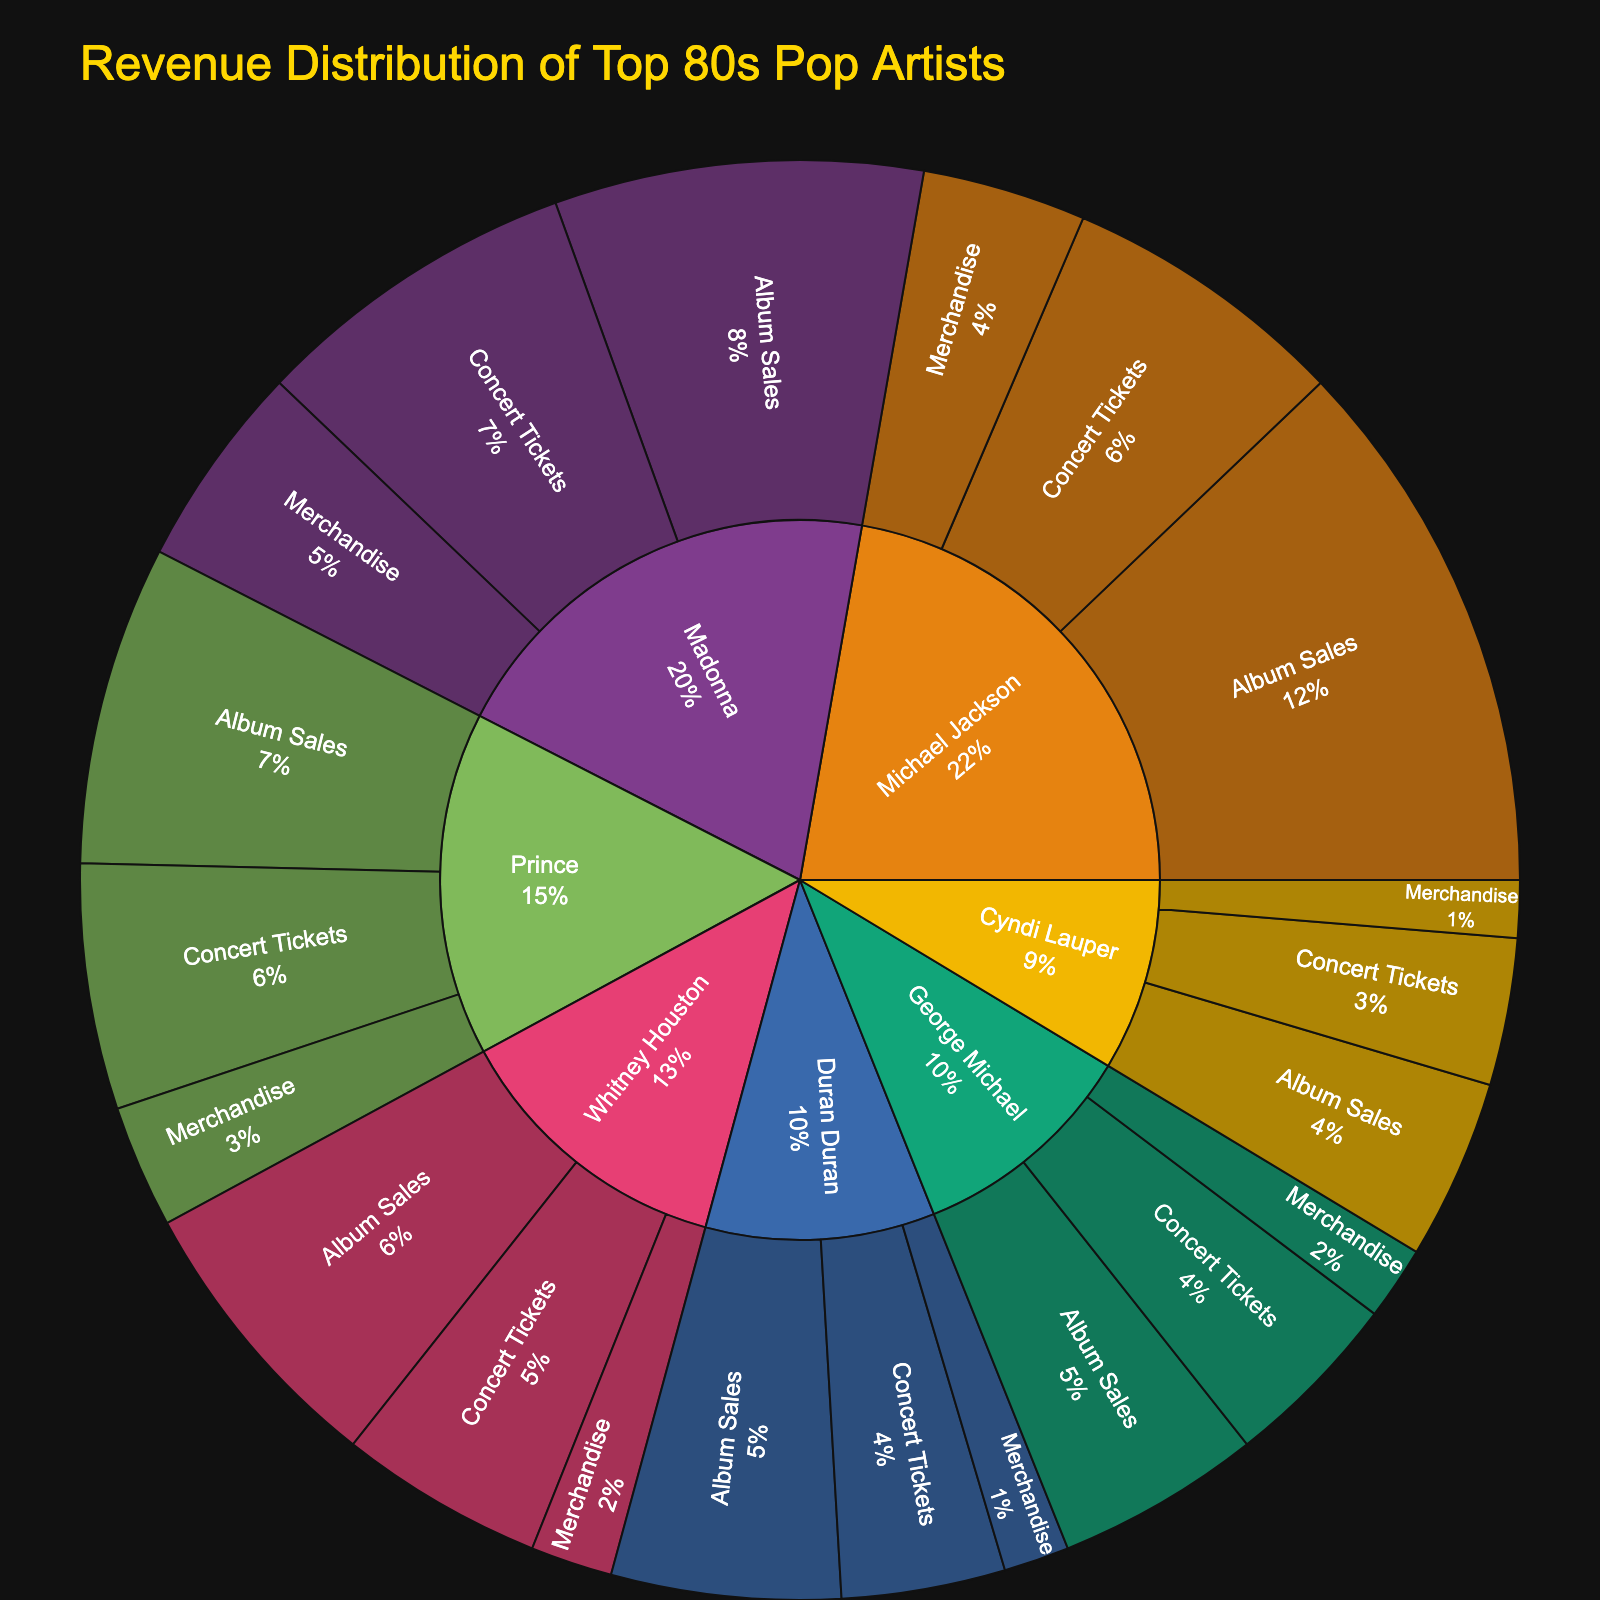what is the total revenue of Michael Jackson? The sunburst plot shows the revenue distribution for each subcategory under Michael Jackson. Summing up the values for Album Sales ($66M), Concert Tickets ($35M), and Merchandise ($20M) gives the total revenue. 66 + 35 + 20 = 121
Answer: 121 which artist has the highest revenue from concert tickets? Referring to each artist's revenue from Concert Tickets, Michael Jackson has $35M, which is the highest compared to others: Madonna ($40M), Prince ($30M), Whitney Houston ($25M), Duran Duran ($20M), Cyndi Lauper ($18M), and George Michael ($22M).
Answer: Madonna what's the percentage revenue from merchandise for Madonna compared to her total revenue? First, find Madonna's total revenue by summing up Album Sales ($45M), Concert Tickets ($40M), and Merchandise ($25M), which is 45 + 40 + 25 = 110. The percentage is then calculated by (25/110) * 100, which is approximately 22.73%.
Answer: 22.73% who generates more total revenue, Prince or Whitney Houston? Calculate the total revenue for both artists. Prince: Album Sales ($39M) + Concert Tickets ($30M) + Merchandise ($15M) = 39 + 30 + 15 = 84. Whitney Houston: Album Sales ($35M) + Concert Tickets ($25M) + Merchandise ($10M) = 35 + 25 + 10 = 70.
Answer: Prince what is the title of the plot? The title is prominently displayed at the top of the plot.
Answer: Revenue Distribution of Top 80s Pop Artists which category contributes most to George Michael's total revenue? Looking at George Michael's data, Album Sales ($25M), Concert Tickets ($22M), and Merchandise ($9M). Album Sales is the highest category.
Answer: Album Sales how much revenue has Duran Duran generated from merchandise? The plot shows Duran Duran's revenue distribution, with Merchandise contributing $8M.
Answer: 8 compare the total revenue from merchandise between Michael Jackson and Prince. Calculate the total revenue from Merchandise for both artists. Michael Jackson: $20M, Prince: $15M. Michael Jackson has a higher revenue from Merchandise.
Answer: Michael Jackson which artist has the smallest total revenue, and what is that amount? From calculating all total revenues: Michael Jackson ($121M), Madonna ($110M), Prince ($84M), Whitney Houston ($70M), Duran Duran ($56M), Cyndi Lauper ($47M), George Michael ($56M). Cyndi Lauper has the smallest total revenue.
Answer: Cyndi Lauper with $47M 